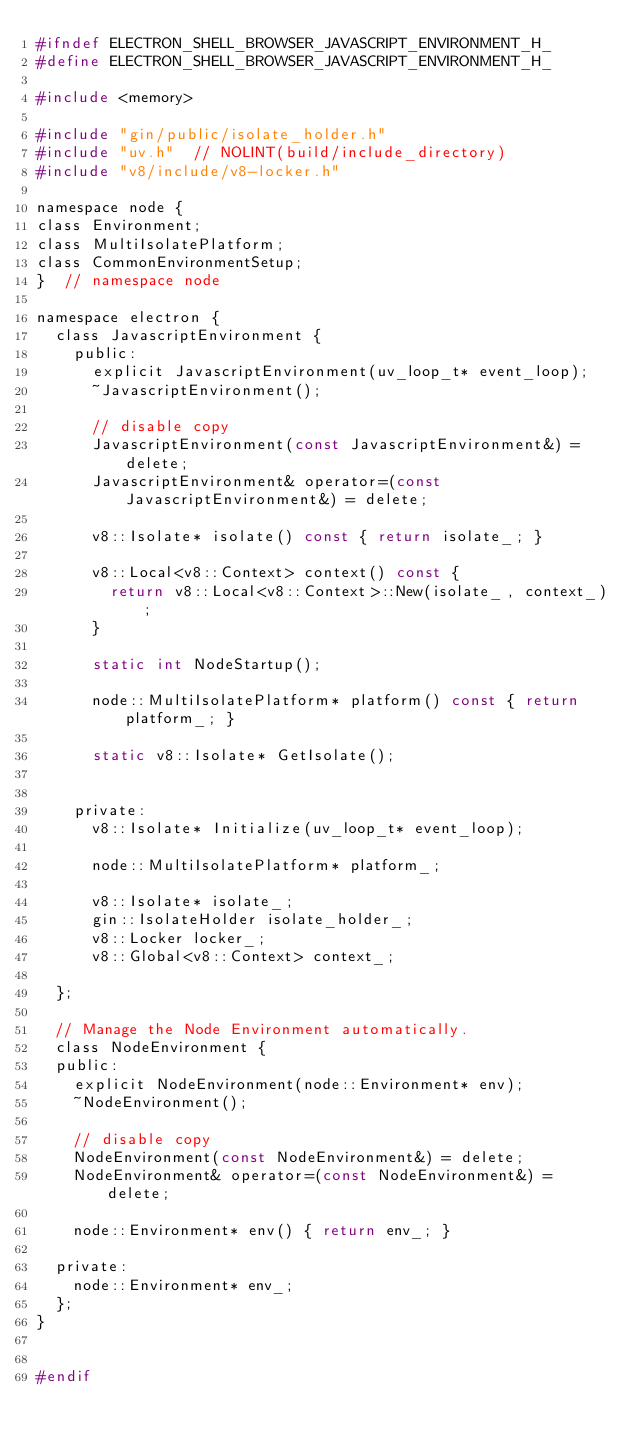Convert code to text. <code><loc_0><loc_0><loc_500><loc_500><_C_>#ifndef ELECTRON_SHELL_BROWSER_JAVASCRIPT_ENVIRONMENT_H_
#define ELECTRON_SHELL_BROWSER_JAVASCRIPT_ENVIRONMENT_H_

#include <memory>

#include "gin/public/isolate_holder.h"
#include "uv.h"  // NOLINT(build/include_directory)
#include "v8/include/v8-locker.h"

namespace node {
class Environment;
class MultiIsolatePlatform;
class CommonEnvironmentSetup;
}  // namespace node

namespace electron {
  class JavascriptEnvironment {
    public:
      explicit JavascriptEnvironment(uv_loop_t* event_loop);
      ~JavascriptEnvironment();

      // disable copy
      JavascriptEnvironment(const JavascriptEnvironment&) = delete;
      JavascriptEnvironment& operator=(const JavascriptEnvironment&) = delete;

      v8::Isolate* isolate() const { return isolate_; }

      v8::Local<v8::Context> context() const {
        return v8::Local<v8::Context>::New(isolate_, context_);
      }

      static int NodeStartup(); 

      node::MultiIsolatePlatform* platform() const { return platform_; }

      static v8::Isolate* GetIsolate();


    private:
      v8::Isolate* Initialize(uv_loop_t* event_loop);

      node::MultiIsolatePlatform* platform_;
  
      v8::Isolate* isolate_;
      gin::IsolateHolder isolate_holder_;
      v8::Locker locker_;
      v8::Global<v8::Context> context_;        

  };

  // Manage the Node Environment automatically.
  class NodeEnvironment {
  public:
    explicit NodeEnvironment(node::Environment* env);
    ~NodeEnvironment();

    // disable copy
    NodeEnvironment(const NodeEnvironment&) = delete;
    NodeEnvironment& operator=(const NodeEnvironment&) = delete;

    node::Environment* env() { return env_; }

  private:
    node::Environment* env_;
  };
}


#endif</code> 